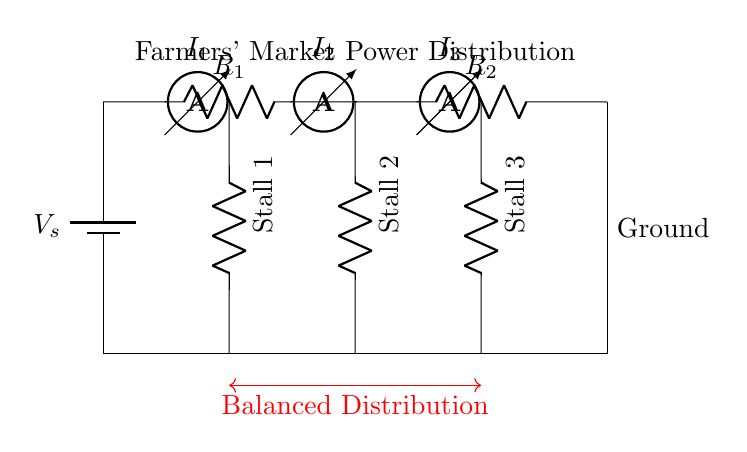What is the main component of this circuit? The main component is the battery, which serves as the power source for the entire circuit. It's represented with the symbol for a battery.
Answer: Battery How many stalls are there in the circuit? There are three stalls represented as loads in this circuit, each connected in parallel to the power distribution.
Answer: Three What is the purpose of the ammeters in this circuit? The ammeters measure the current flowing through each stall, allowing for the monitoring of power distribution among them.
Answer: Measure current Which stall is the first in the circuit? Stall 1 is the first load connected in the series of stalls, positioned closest to the power source.
Answer: Stall 1 How is the current distributed among the stalls? The current is divided among the stalls based on the resistance of each load; this is characteristic of a current divider circuit where total current from the source is shared.
Answer: Divided current What is the total resistance in the circuit? The total resistance can be calculated using the formula for resistors in parallel, which involves each stall's resistance, but generally, it equals the sum of the individual resistances.
Answer: Total resistance depends on R1 and R2 What does the red annotation indicate in this circuit diagram? The red annotation indicates balanced distribution, suggesting that the power is equally allocated among the stalls connected in parallel to ensure an even power supply.
Answer: Balanced Distribution 